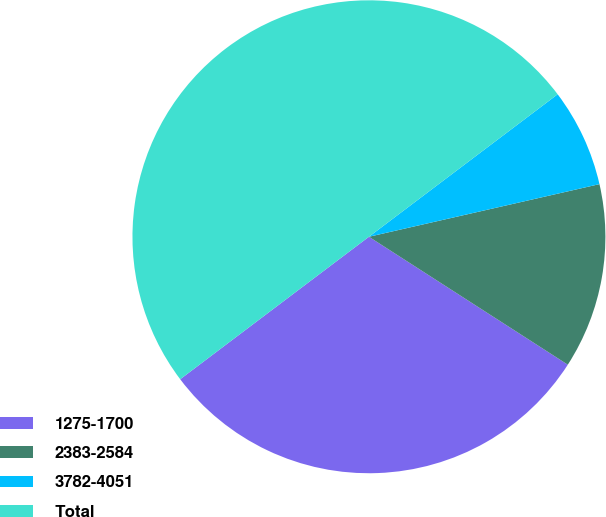<chart> <loc_0><loc_0><loc_500><loc_500><pie_chart><fcel>1275-1700<fcel>2383-2584<fcel>3782-4051<fcel>Total<nl><fcel>30.61%<fcel>12.67%<fcel>6.72%<fcel>50.0%<nl></chart> 